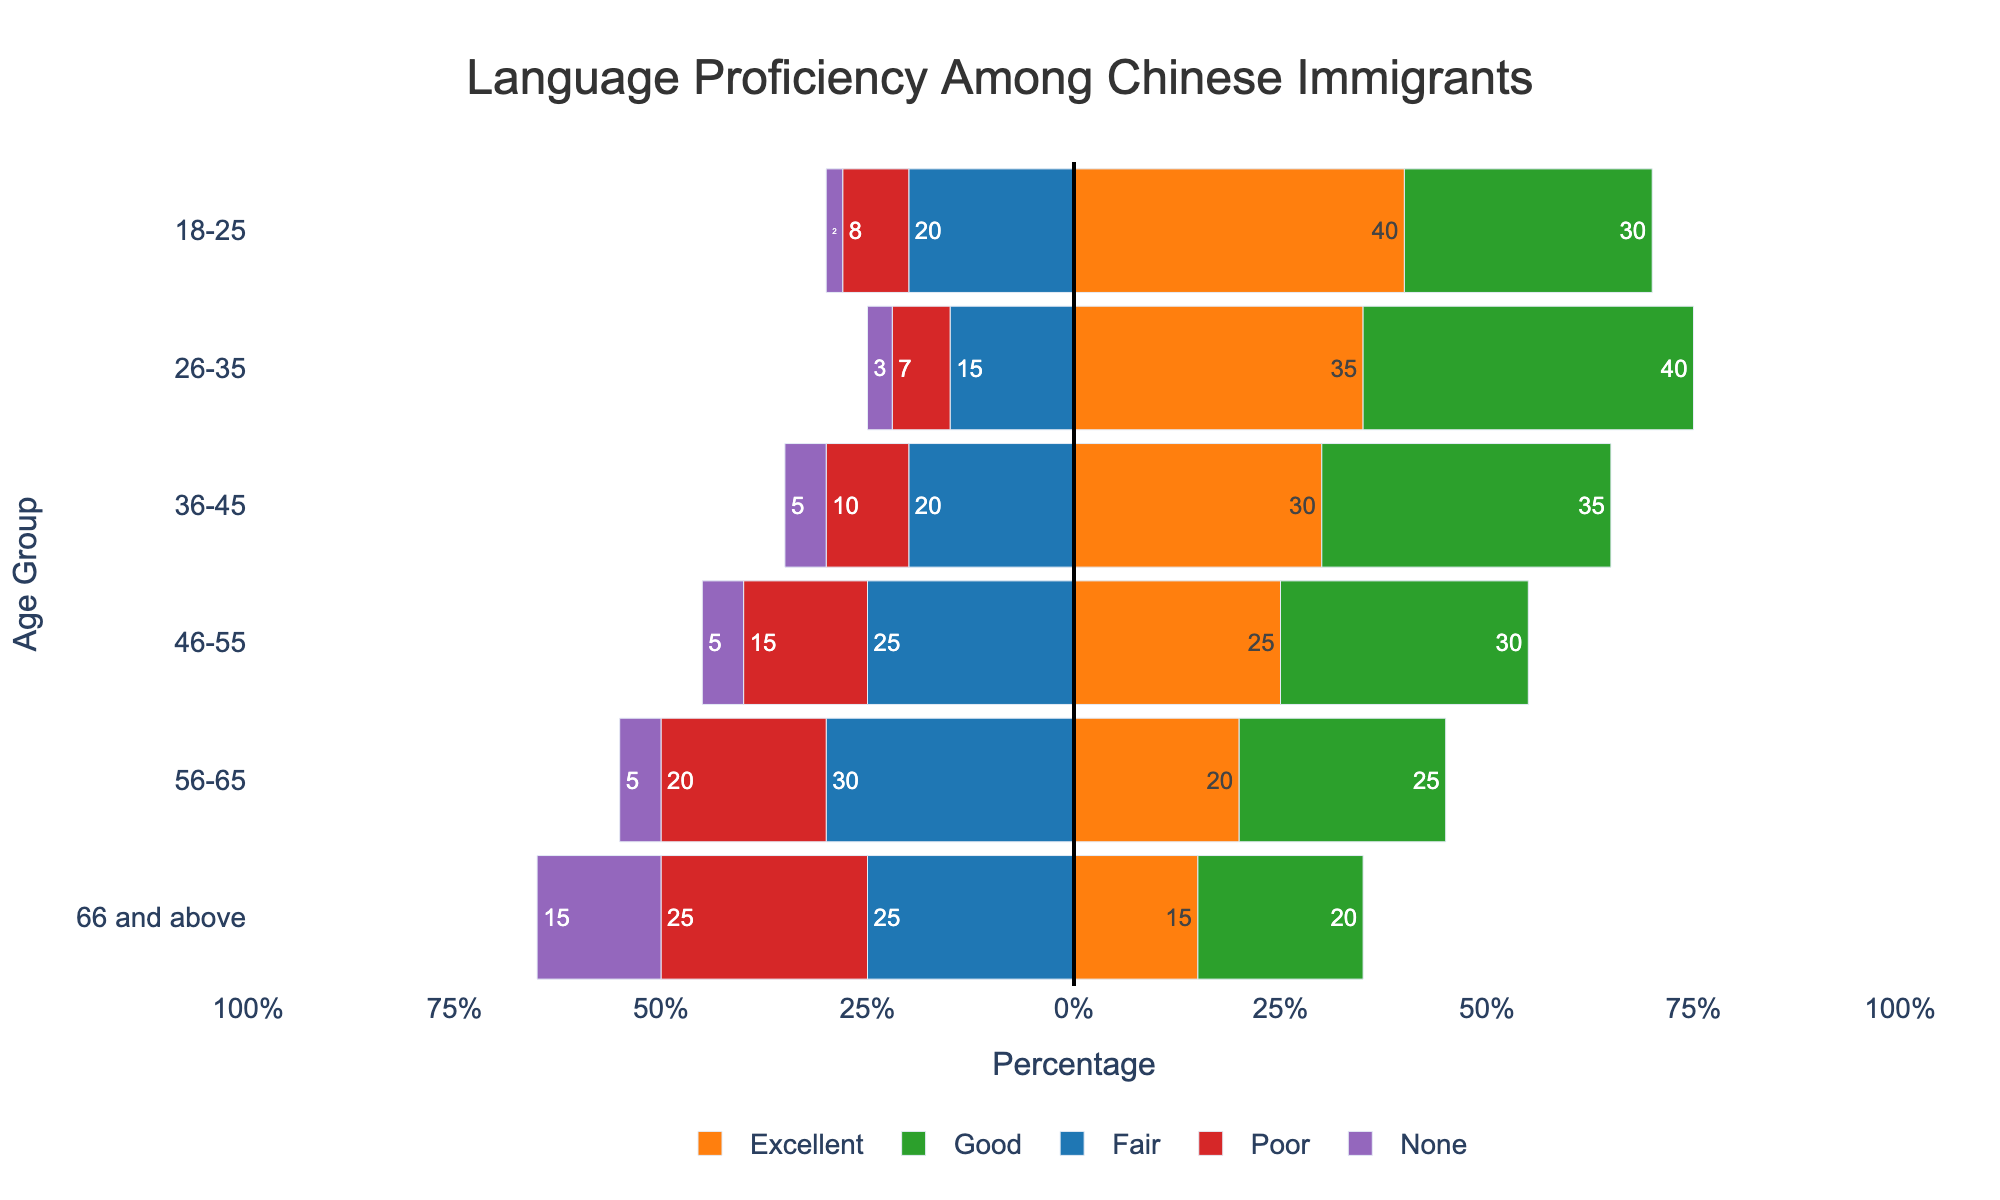Which age group has the highest percentage of excellent language proficiency? To find the age group with the highest percentage of excellent proficiency, we simply compare the values given for "Excellent" in the dataset. The highest value is 40% for the 18-25 age group.
Answer: 18-25 Among the groups aged 36-45, which language proficiency categories have negative bars? Negative bars represent fairness or lower proficiency categories (Fair, Poor, None). For the 36-45 age group, the negative bars are for Fair (20%), Poor (10%), and None (5%).
Answer: Fair, Poor, None What's the combined percentage of people who have poor or no proficiency in the 66 and above age group? To find this, sum the percentages for Poor and None in the 66 and above group. This is 25% (Poor) + 15% (None) = 40%.
Answer: 40% Which age group shows an equal percentage of Good and Fair proficiency? Comparing the Good and Fair columns, the 36-45 age group shows Good (35%) and Fair (35%), indicating equal percentages.
Answer: 36-45 How does the percentage of people with excellent proficiency compare between the 26-35 and 56-65 age groups? The percentage of people with excellent proficiency is 35% for the 26-35 age group and 20% for the 56-65 age group. Thus, the 26-35 age group has a higher percentage.
Answer: 26-35 > 56-65 What is the trend of excellent language proficiency as age increases? Observing the "Excellent" values as age increases (from 18-25 to 66 and above), we see a decreasing trend: 40%, 35%, 30%, 25%, 20%, 15%.
Answer: Decreasing Calculate the difference in the percentage of poor proficiency between the 46-55 and 56-65 age groups. To find the difference, subtract the percentage of poor proficiency in 56-65 (20%) from that in 46-55 (15%). The difference is 20% - 15% = 5%.
Answer: 5% What visual traits distinguish the "Good" proficiency category in the plot? The "Good" category bars are green and positioned to the right side of the vertical line at 0. They also occupy significant positive values on the x-axis.
Answer: Green, right-side, positive values What age group has the most balanced proficiency levels, with the least extreme values? The 46-55 age group has the least variation in proficiency levels, ranging from 2% to 25% across categories, making it the most balanced.
Answer: 46-55 